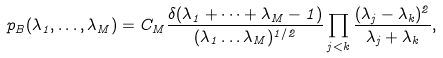Convert formula to latex. <formula><loc_0><loc_0><loc_500><loc_500>p _ { B } ( \lambda _ { 1 } , \dots , \lambda _ { M } ) = C _ { M } \frac { \delta ( \lambda _ { 1 } + \dots + \lambda _ { M } - 1 ) } { ( \lambda _ { 1 } \dots \lambda _ { M } ) ^ { 1 / 2 } } \prod _ { j < k } \frac { ( \lambda _ { j } - \lambda _ { k } ) ^ { 2 } } { \lambda _ { j } + \lambda _ { k } } ,</formula> 